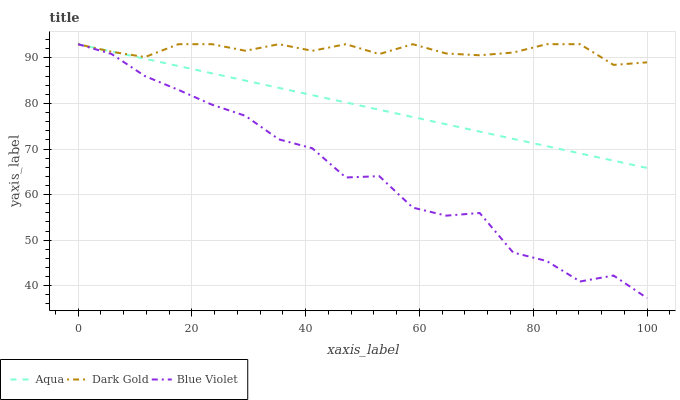Does Blue Violet have the minimum area under the curve?
Answer yes or no. Yes. Does Dark Gold have the maximum area under the curve?
Answer yes or no. Yes. Does Dark Gold have the minimum area under the curve?
Answer yes or no. No. Does Blue Violet have the maximum area under the curve?
Answer yes or no. No. Is Aqua the smoothest?
Answer yes or no. Yes. Is Blue Violet the roughest?
Answer yes or no. Yes. Is Dark Gold the smoothest?
Answer yes or no. No. Is Dark Gold the roughest?
Answer yes or no. No. Does Blue Violet have the lowest value?
Answer yes or no. Yes. Does Dark Gold have the lowest value?
Answer yes or no. No. Does Dark Gold have the highest value?
Answer yes or no. Yes. Does Blue Violet intersect Aqua?
Answer yes or no. Yes. Is Blue Violet less than Aqua?
Answer yes or no. No. Is Blue Violet greater than Aqua?
Answer yes or no. No. 